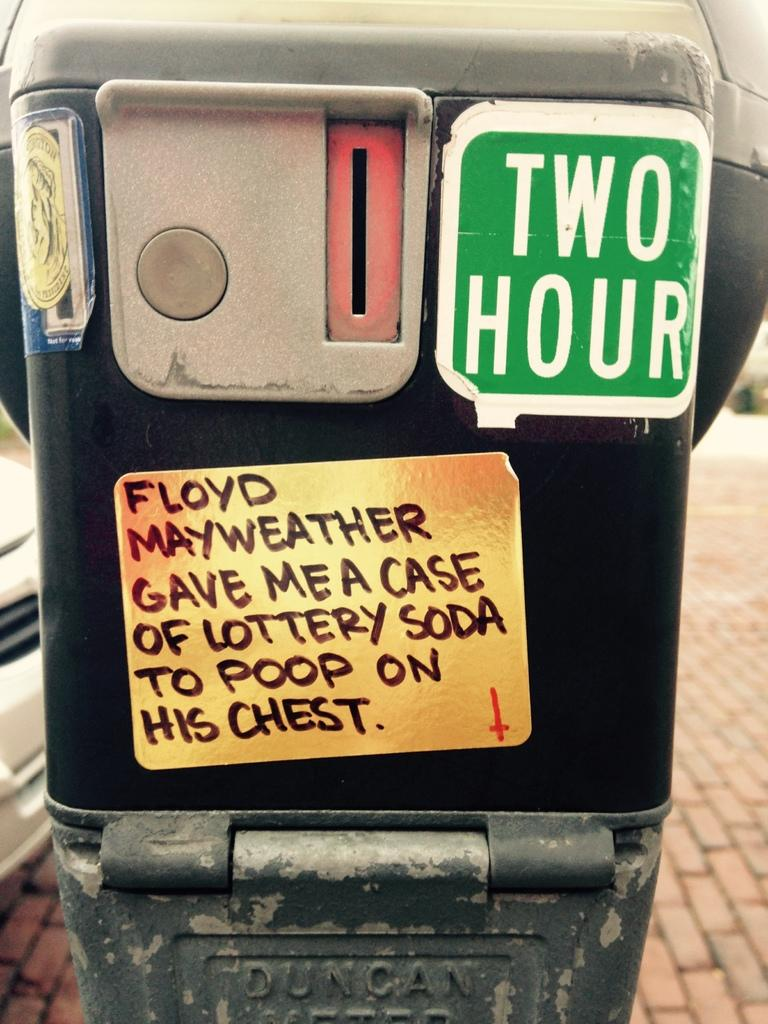<image>
Relay a brief, clear account of the picture shown. A sticker on the parking meter has a joke about Floyd Mayweather. 